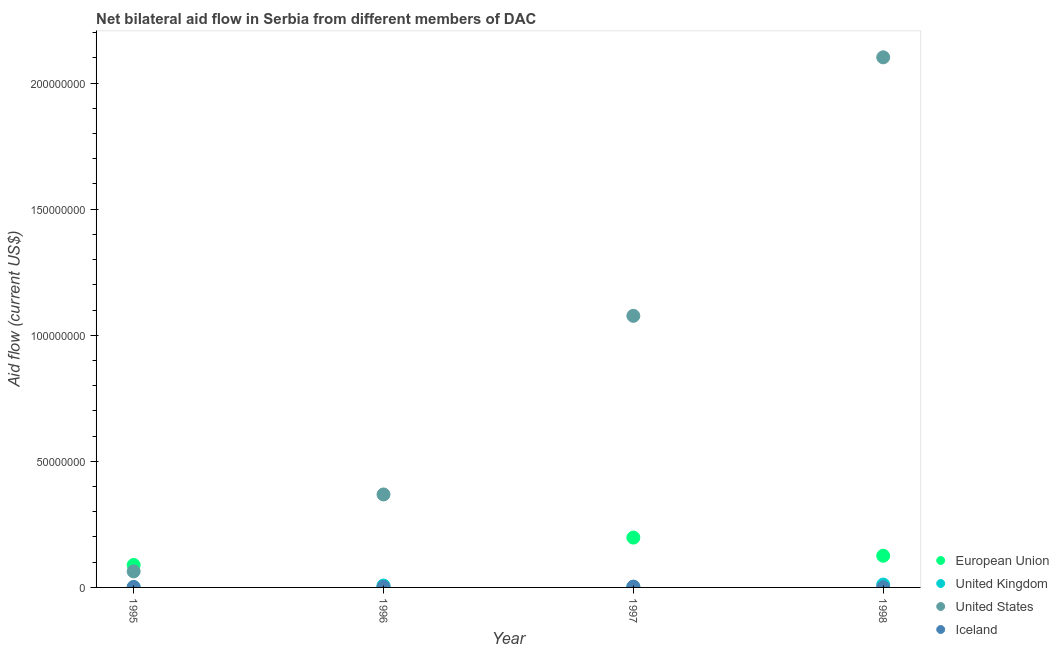How many different coloured dotlines are there?
Ensure brevity in your answer.  4. Is the number of dotlines equal to the number of legend labels?
Your answer should be very brief. Yes. What is the amount of aid given by uk in 1997?
Offer a terse response. 2.10e+05. Across all years, what is the maximum amount of aid given by eu?
Ensure brevity in your answer.  1.98e+07. Across all years, what is the minimum amount of aid given by uk?
Provide a succinct answer. 4.00e+04. What is the total amount of aid given by us in the graph?
Your response must be concise. 3.61e+08. What is the difference between the amount of aid given by us in 1995 and that in 1998?
Give a very brief answer. -2.04e+08. What is the difference between the amount of aid given by eu in 1997 and the amount of aid given by us in 1996?
Make the answer very short. -1.71e+07. What is the average amount of aid given by uk per year?
Give a very brief answer. 5.32e+05. In the year 1997, what is the difference between the amount of aid given by eu and amount of aid given by uk?
Your answer should be very brief. 1.96e+07. In how many years, is the amount of aid given by eu greater than 210000000 US$?
Offer a terse response. 0. What is the ratio of the amount of aid given by us in 1996 to that in 1998?
Provide a short and direct response. 0.18. What is the difference between the highest and the second highest amount of aid given by us?
Offer a very short reply. 1.03e+08. What is the difference between the highest and the lowest amount of aid given by eu?
Ensure brevity in your answer.  1.97e+07. In how many years, is the amount of aid given by eu greater than the average amount of aid given by eu taken over all years?
Your answer should be very brief. 2. Is it the case that in every year, the sum of the amount of aid given by eu and amount of aid given by uk is greater than the amount of aid given by us?
Provide a succinct answer. No. Does the amount of aid given by us monotonically increase over the years?
Provide a succinct answer. Yes. How many dotlines are there?
Make the answer very short. 4. Does the graph contain any zero values?
Your response must be concise. No. Does the graph contain grids?
Make the answer very short. No. Where does the legend appear in the graph?
Make the answer very short. Bottom right. What is the title of the graph?
Ensure brevity in your answer.  Net bilateral aid flow in Serbia from different members of DAC. What is the label or title of the X-axis?
Your answer should be compact. Year. What is the label or title of the Y-axis?
Ensure brevity in your answer.  Aid flow (current US$). What is the Aid flow (current US$) in European Union in 1995?
Make the answer very short. 8.90e+06. What is the Aid flow (current US$) of United Kingdom in 1995?
Provide a short and direct response. 4.00e+04. What is the Aid flow (current US$) of United States in 1995?
Provide a short and direct response. 6.36e+06. What is the Aid flow (current US$) in United Kingdom in 1996?
Make the answer very short. 7.50e+05. What is the Aid flow (current US$) of United States in 1996?
Keep it short and to the point. 3.69e+07. What is the Aid flow (current US$) in European Union in 1997?
Offer a very short reply. 1.98e+07. What is the Aid flow (current US$) in United States in 1997?
Make the answer very short. 1.08e+08. What is the Aid flow (current US$) of European Union in 1998?
Give a very brief answer. 1.26e+07. What is the Aid flow (current US$) of United Kingdom in 1998?
Give a very brief answer. 1.13e+06. What is the Aid flow (current US$) in United States in 1998?
Your answer should be compact. 2.10e+08. What is the Aid flow (current US$) of Iceland in 1998?
Your answer should be compact. 7.00e+04. Across all years, what is the maximum Aid flow (current US$) in European Union?
Offer a very short reply. 1.98e+07. Across all years, what is the maximum Aid flow (current US$) in United Kingdom?
Make the answer very short. 1.13e+06. Across all years, what is the maximum Aid flow (current US$) of United States?
Provide a succinct answer. 2.10e+08. Across all years, what is the maximum Aid flow (current US$) of Iceland?
Provide a succinct answer. 3.20e+05. Across all years, what is the minimum Aid flow (current US$) of United Kingdom?
Provide a succinct answer. 4.00e+04. Across all years, what is the minimum Aid flow (current US$) of United States?
Ensure brevity in your answer.  6.36e+06. What is the total Aid flow (current US$) in European Union in the graph?
Provide a succinct answer. 4.13e+07. What is the total Aid flow (current US$) in United Kingdom in the graph?
Your answer should be very brief. 2.13e+06. What is the total Aid flow (current US$) of United States in the graph?
Ensure brevity in your answer.  3.61e+08. What is the total Aid flow (current US$) in Iceland in the graph?
Your answer should be compact. 7.90e+05. What is the difference between the Aid flow (current US$) in European Union in 1995 and that in 1996?
Provide a succinct answer. 8.81e+06. What is the difference between the Aid flow (current US$) in United Kingdom in 1995 and that in 1996?
Make the answer very short. -7.10e+05. What is the difference between the Aid flow (current US$) of United States in 1995 and that in 1996?
Your answer should be very brief. -3.05e+07. What is the difference between the Aid flow (current US$) in European Union in 1995 and that in 1997?
Ensure brevity in your answer.  -1.09e+07. What is the difference between the Aid flow (current US$) in United Kingdom in 1995 and that in 1997?
Your response must be concise. -1.70e+05. What is the difference between the Aid flow (current US$) in United States in 1995 and that in 1997?
Ensure brevity in your answer.  -1.01e+08. What is the difference between the Aid flow (current US$) of European Union in 1995 and that in 1998?
Ensure brevity in your answer.  -3.66e+06. What is the difference between the Aid flow (current US$) in United Kingdom in 1995 and that in 1998?
Keep it short and to the point. -1.09e+06. What is the difference between the Aid flow (current US$) of United States in 1995 and that in 1998?
Offer a terse response. -2.04e+08. What is the difference between the Aid flow (current US$) of Iceland in 1995 and that in 1998?
Offer a very short reply. 1.10e+05. What is the difference between the Aid flow (current US$) in European Union in 1996 and that in 1997?
Your answer should be very brief. -1.97e+07. What is the difference between the Aid flow (current US$) in United Kingdom in 1996 and that in 1997?
Provide a short and direct response. 5.40e+05. What is the difference between the Aid flow (current US$) of United States in 1996 and that in 1997?
Give a very brief answer. -7.08e+07. What is the difference between the Aid flow (current US$) of European Union in 1996 and that in 1998?
Give a very brief answer. -1.25e+07. What is the difference between the Aid flow (current US$) in United Kingdom in 1996 and that in 1998?
Ensure brevity in your answer.  -3.80e+05. What is the difference between the Aid flow (current US$) of United States in 1996 and that in 1998?
Your answer should be compact. -1.73e+08. What is the difference between the Aid flow (current US$) in European Union in 1997 and that in 1998?
Offer a very short reply. 7.20e+06. What is the difference between the Aid flow (current US$) in United Kingdom in 1997 and that in 1998?
Offer a very short reply. -9.20e+05. What is the difference between the Aid flow (current US$) of United States in 1997 and that in 1998?
Make the answer very short. -1.03e+08. What is the difference between the Aid flow (current US$) in European Union in 1995 and the Aid flow (current US$) in United Kingdom in 1996?
Ensure brevity in your answer.  8.15e+06. What is the difference between the Aid flow (current US$) in European Union in 1995 and the Aid flow (current US$) in United States in 1996?
Provide a short and direct response. -2.80e+07. What is the difference between the Aid flow (current US$) of European Union in 1995 and the Aid flow (current US$) of Iceland in 1996?
Your answer should be very brief. 8.68e+06. What is the difference between the Aid flow (current US$) in United Kingdom in 1995 and the Aid flow (current US$) in United States in 1996?
Ensure brevity in your answer.  -3.68e+07. What is the difference between the Aid flow (current US$) in United States in 1995 and the Aid flow (current US$) in Iceland in 1996?
Your answer should be compact. 6.14e+06. What is the difference between the Aid flow (current US$) of European Union in 1995 and the Aid flow (current US$) of United Kingdom in 1997?
Give a very brief answer. 8.69e+06. What is the difference between the Aid flow (current US$) in European Union in 1995 and the Aid flow (current US$) in United States in 1997?
Offer a terse response. -9.88e+07. What is the difference between the Aid flow (current US$) in European Union in 1995 and the Aid flow (current US$) in Iceland in 1997?
Offer a terse response. 8.58e+06. What is the difference between the Aid flow (current US$) in United Kingdom in 1995 and the Aid flow (current US$) in United States in 1997?
Ensure brevity in your answer.  -1.08e+08. What is the difference between the Aid flow (current US$) of United Kingdom in 1995 and the Aid flow (current US$) of Iceland in 1997?
Keep it short and to the point. -2.80e+05. What is the difference between the Aid flow (current US$) in United States in 1995 and the Aid flow (current US$) in Iceland in 1997?
Your answer should be very brief. 6.04e+06. What is the difference between the Aid flow (current US$) in European Union in 1995 and the Aid flow (current US$) in United Kingdom in 1998?
Offer a very short reply. 7.77e+06. What is the difference between the Aid flow (current US$) in European Union in 1995 and the Aid flow (current US$) in United States in 1998?
Keep it short and to the point. -2.01e+08. What is the difference between the Aid flow (current US$) of European Union in 1995 and the Aid flow (current US$) of Iceland in 1998?
Your response must be concise. 8.83e+06. What is the difference between the Aid flow (current US$) in United Kingdom in 1995 and the Aid flow (current US$) in United States in 1998?
Your response must be concise. -2.10e+08. What is the difference between the Aid flow (current US$) of United States in 1995 and the Aid flow (current US$) of Iceland in 1998?
Keep it short and to the point. 6.29e+06. What is the difference between the Aid flow (current US$) of European Union in 1996 and the Aid flow (current US$) of United Kingdom in 1997?
Offer a very short reply. -1.20e+05. What is the difference between the Aid flow (current US$) in European Union in 1996 and the Aid flow (current US$) in United States in 1997?
Offer a very short reply. -1.08e+08. What is the difference between the Aid flow (current US$) in United Kingdom in 1996 and the Aid flow (current US$) in United States in 1997?
Your response must be concise. -1.07e+08. What is the difference between the Aid flow (current US$) of United States in 1996 and the Aid flow (current US$) of Iceland in 1997?
Your response must be concise. 3.66e+07. What is the difference between the Aid flow (current US$) of European Union in 1996 and the Aid flow (current US$) of United Kingdom in 1998?
Provide a short and direct response. -1.04e+06. What is the difference between the Aid flow (current US$) in European Union in 1996 and the Aid flow (current US$) in United States in 1998?
Make the answer very short. -2.10e+08. What is the difference between the Aid flow (current US$) of United Kingdom in 1996 and the Aid flow (current US$) of United States in 1998?
Offer a terse response. -2.09e+08. What is the difference between the Aid flow (current US$) of United Kingdom in 1996 and the Aid flow (current US$) of Iceland in 1998?
Your answer should be very brief. 6.80e+05. What is the difference between the Aid flow (current US$) of United States in 1996 and the Aid flow (current US$) of Iceland in 1998?
Your answer should be compact. 3.68e+07. What is the difference between the Aid flow (current US$) of European Union in 1997 and the Aid flow (current US$) of United Kingdom in 1998?
Provide a short and direct response. 1.86e+07. What is the difference between the Aid flow (current US$) of European Union in 1997 and the Aid flow (current US$) of United States in 1998?
Offer a very short reply. -1.90e+08. What is the difference between the Aid flow (current US$) of European Union in 1997 and the Aid flow (current US$) of Iceland in 1998?
Your response must be concise. 1.97e+07. What is the difference between the Aid flow (current US$) of United Kingdom in 1997 and the Aid flow (current US$) of United States in 1998?
Your response must be concise. -2.10e+08. What is the difference between the Aid flow (current US$) of United States in 1997 and the Aid flow (current US$) of Iceland in 1998?
Offer a very short reply. 1.08e+08. What is the average Aid flow (current US$) of European Union per year?
Provide a succinct answer. 1.03e+07. What is the average Aid flow (current US$) of United Kingdom per year?
Provide a short and direct response. 5.32e+05. What is the average Aid flow (current US$) in United States per year?
Give a very brief answer. 9.03e+07. What is the average Aid flow (current US$) in Iceland per year?
Your answer should be compact. 1.98e+05. In the year 1995, what is the difference between the Aid flow (current US$) of European Union and Aid flow (current US$) of United Kingdom?
Provide a short and direct response. 8.86e+06. In the year 1995, what is the difference between the Aid flow (current US$) of European Union and Aid flow (current US$) of United States?
Keep it short and to the point. 2.54e+06. In the year 1995, what is the difference between the Aid flow (current US$) in European Union and Aid flow (current US$) in Iceland?
Offer a very short reply. 8.72e+06. In the year 1995, what is the difference between the Aid flow (current US$) of United Kingdom and Aid flow (current US$) of United States?
Keep it short and to the point. -6.32e+06. In the year 1995, what is the difference between the Aid flow (current US$) of United States and Aid flow (current US$) of Iceland?
Your answer should be compact. 6.18e+06. In the year 1996, what is the difference between the Aid flow (current US$) of European Union and Aid flow (current US$) of United Kingdom?
Make the answer very short. -6.60e+05. In the year 1996, what is the difference between the Aid flow (current US$) in European Union and Aid flow (current US$) in United States?
Offer a terse response. -3.68e+07. In the year 1996, what is the difference between the Aid flow (current US$) in European Union and Aid flow (current US$) in Iceland?
Your answer should be compact. -1.30e+05. In the year 1996, what is the difference between the Aid flow (current US$) in United Kingdom and Aid flow (current US$) in United States?
Offer a very short reply. -3.61e+07. In the year 1996, what is the difference between the Aid flow (current US$) in United Kingdom and Aid flow (current US$) in Iceland?
Offer a very short reply. 5.30e+05. In the year 1996, what is the difference between the Aid flow (current US$) in United States and Aid flow (current US$) in Iceland?
Offer a very short reply. 3.66e+07. In the year 1997, what is the difference between the Aid flow (current US$) in European Union and Aid flow (current US$) in United Kingdom?
Your answer should be very brief. 1.96e+07. In the year 1997, what is the difference between the Aid flow (current US$) in European Union and Aid flow (current US$) in United States?
Make the answer very short. -8.79e+07. In the year 1997, what is the difference between the Aid flow (current US$) of European Union and Aid flow (current US$) of Iceland?
Provide a short and direct response. 1.94e+07. In the year 1997, what is the difference between the Aid flow (current US$) of United Kingdom and Aid flow (current US$) of United States?
Ensure brevity in your answer.  -1.07e+08. In the year 1997, what is the difference between the Aid flow (current US$) in United States and Aid flow (current US$) in Iceland?
Give a very brief answer. 1.07e+08. In the year 1998, what is the difference between the Aid flow (current US$) of European Union and Aid flow (current US$) of United Kingdom?
Make the answer very short. 1.14e+07. In the year 1998, what is the difference between the Aid flow (current US$) in European Union and Aid flow (current US$) in United States?
Your answer should be very brief. -1.98e+08. In the year 1998, what is the difference between the Aid flow (current US$) in European Union and Aid flow (current US$) in Iceland?
Your answer should be compact. 1.25e+07. In the year 1998, what is the difference between the Aid flow (current US$) in United Kingdom and Aid flow (current US$) in United States?
Provide a short and direct response. -2.09e+08. In the year 1998, what is the difference between the Aid flow (current US$) in United Kingdom and Aid flow (current US$) in Iceland?
Ensure brevity in your answer.  1.06e+06. In the year 1998, what is the difference between the Aid flow (current US$) of United States and Aid flow (current US$) of Iceland?
Your answer should be very brief. 2.10e+08. What is the ratio of the Aid flow (current US$) of European Union in 1995 to that in 1996?
Provide a short and direct response. 98.89. What is the ratio of the Aid flow (current US$) of United Kingdom in 1995 to that in 1996?
Give a very brief answer. 0.05. What is the ratio of the Aid flow (current US$) in United States in 1995 to that in 1996?
Keep it short and to the point. 0.17. What is the ratio of the Aid flow (current US$) of Iceland in 1995 to that in 1996?
Give a very brief answer. 0.82. What is the ratio of the Aid flow (current US$) in European Union in 1995 to that in 1997?
Offer a terse response. 0.45. What is the ratio of the Aid flow (current US$) in United Kingdom in 1995 to that in 1997?
Offer a very short reply. 0.19. What is the ratio of the Aid flow (current US$) in United States in 1995 to that in 1997?
Provide a succinct answer. 0.06. What is the ratio of the Aid flow (current US$) in Iceland in 1995 to that in 1997?
Your response must be concise. 0.56. What is the ratio of the Aid flow (current US$) of European Union in 1995 to that in 1998?
Make the answer very short. 0.71. What is the ratio of the Aid flow (current US$) in United Kingdom in 1995 to that in 1998?
Offer a very short reply. 0.04. What is the ratio of the Aid flow (current US$) of United States in 1995 to that in 1998?
Your response must be concise. 0.03. What is the ratio of the Aid flow (current US$) in Iceland in 1995 to that in 1998?
Your response must be concise. 2.57. What is the ratio of the Aid flow (current US$) of European Union in 1996 to that in 1997?
Your answer should be very brief. 0. What is the ratio of the Aid flow (current US$) in United Kingdom in 1996 to that in 1997?
Ensure brevity in your answer.  3.57. What is the ratio of the Aid flow (current US$) in United States in 1996 to that in 1997?
Provide a short and direct response. 0.34. What is the ratio of the Aid flow (current US$) in Iceland in 1996 to that in 1997?
Make the answer very short. 0.69. What is the ratio of the Aid flow (current US$) in European Union in 1996 to that in 1998?
Your answer should be compact. 0.01. What is the ratio of the Aid flow (current US$) in United Kingdom in 1996 to that in 1998?
Ensure brevity in your answer.  0.66. What is the ratio of the Aid flow (current US$) in United States in 1996 to that in 1998?
Ensure brevity in your answer.  0.18. What is the ratio of the Aid flow (current US$) in Iceland in 1996 to that in 1998?
Ensure brevity in your answer.  3.14. What is the ratio of the Aid flow (current US$) in European Union in 1997 to that in 1998?
Provide a short and direct response. 1.57. What is the ratio of the Aid flow (current US$) of United Kingdom in 1997 to that in 1998?
Provide a short and direct response. 0.19. What is the ratio of the Aid flow (current US$) in United States in 1997 to that in 1998?
Give a very brief answer. 0.51. What is the ratio of the Aid flow (current US$) of Iceland in 1997 to that in 1998?
Your response must be concise. 4.57. What is the difference between the highest and the second highest Aid flow (current US$) in European Union?
Offer a very short reply. 7.20e+06. What is the difference between the highest and the second highest Aid flow (current US$) in United States?
Make the answer very short. 1.03e+08. What is the difference between the highest and the second highest Aid flow (current US$) in Iceland?
Provide a short and direct response. 1.00e+05. What is the difference between the highest and the lowest Aid flow (current US$) in European Union?
Ensure brevity in your answer.  1.97e+07. What is the difference between the highest and the lowest Aid flow (current US$) of United Kingdom?
Make the answer very short. 1.09e+06. What is the difference between the highest and the lowest Aid flow (current US$) in United States?
Ensure brevity in your answer.  2.04e+08. 